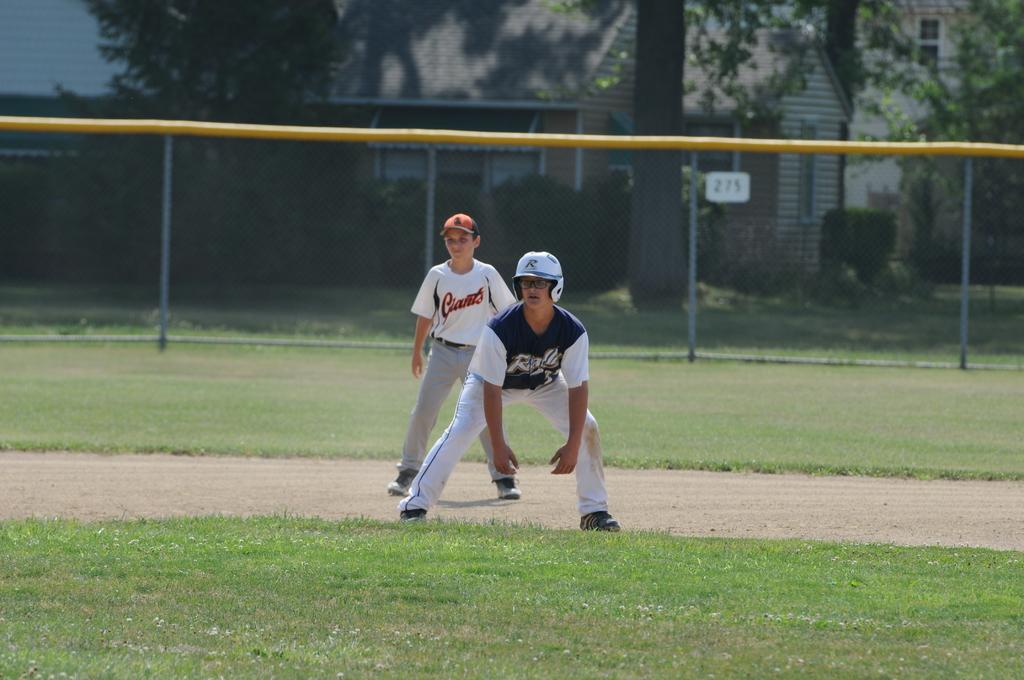What team do these people play for?
Offer a very short reply. Giants. 